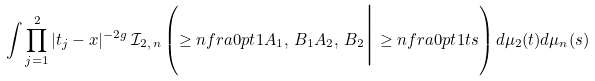<formula> <loc_0><loc_0><loc_500><loc_500>\int \prod _ { j = 1 } ^ { 2 } | t _ { j } - x | ^ { - 2 g } \, \mathcal { I } _ { 2 , \, n } \left ( \geq n f r a { } { 0 p t } { 1 } { A _ { 1 } , \, B _ { 1 } } { A _ { 2 } , \, B _ { 2 } } \Big | \geq n f r a { } { 0 p t } { 1 } { t } { s } \right ) d \mu _ { 2 } ( t ) d \mu _ { n } ( s )</formula> 